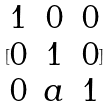Convert formula to latex. <formula><loc_0><loc_0><loc_500><loc_500>[ \begin{matrix} 1 & 0 & 0 \\ 0 & 1 & 0 \\ 0 & a & 1 \end{matrix} ]</formula> 